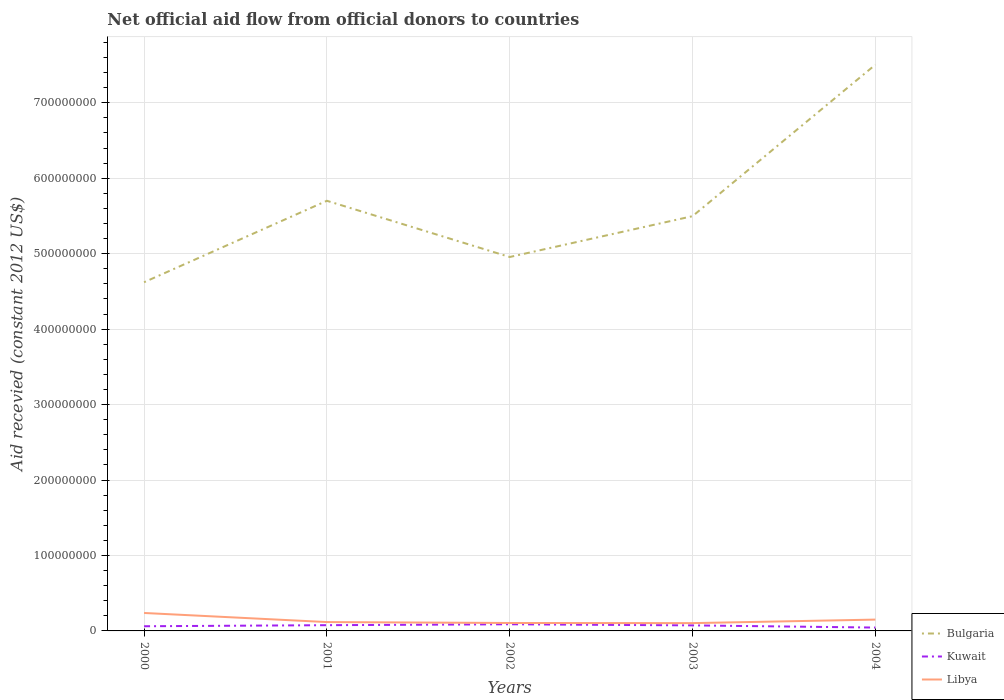How many different coloured lines are there?
Offer a terse response. 3. Across all years, what is the maximum total aid received in Libya?
Your answer should be compact. 1.03e+07. In which year was the total aid received in Libya maximum?
Offer a terse response. 2003. What is the total total aid received in Bulgaria in the graph?
Offer a very short reply. -2.88e+08. What is the difference between the highest and the second highest total aid received in Kuwait?
Ensure brevity in your answer.  4.38e+06. Is the total aid received in Kuwait strictly greater than the total aid received in Bulgaria over the years?
Ensure brevity in your answer.  Yes. How many lines are there?
Your response must be concise. 3. How many years are there in the graph?
Make the answer very short. 5. What is the difference between two consecutive major ticks on the Y-axis?
Your answer should be very brief. 1.00e+08. Are the values on the major ticks of Y-axis written in scientific E-notation?
Ensure brevity in your answer.  No. Does the graph contain grids?
Provide a short and direct response. Yes. Where does the legend appear in the graph?
Make the answer very short. Bottom right. What is the title of the graph?
Your response must be concise. Net official aid flow from official donors to countries. Does "Italy" appear as one of the legend labels in the graph?
Give a very brief answer. No. What is the label or title of the X-axis?
Ensure brevity in your answer.  Years. What is the label or title of the Y-axis?
Provide a succinct answer. Aid recevied (constant 2012 US$). What is the Aid recevied (constant 2012 US$) in Bulgaria in 2000?
Make the answer very short. 4.62e+08. What is the Aid recevied (constant 2012 US$) of Kuwait in 2000?
Your answer should be very brief. 6.19e+06. What is the Aid recevied (constant 2012 US$) of Libya in 2000?
Provide a short and direct response. 2.38e+07. What is the Aid recevied (constant 2012 US$) in Bulgaria in 2001?
Your answer should be compact. 5.70e+08. What is the Aid recevied (constant 2012 US$) of Kuwait in 2001?
Ensure brevity in your answer.  7.60e+06. What is the Aid recevied (constant 2012 US$) in Libya in 2001?
Provide a short and direct response. 1.17e+07. What is the Aid recevied (constant 2012 US$) in Bulgaria in 2002?
Your response must be concise. 4.96e+08. What is the Aid recevied (constant 2012 US$) of Kuwait in 2002?
Ensure brevity in your answer.  8.82e+06. What is the Aid recevied (constant 2012 US$) of Libya in 2002?
Your response must be concise. 1.05e+07. What is the Aid recevied (constant 2012 US$) in Bulgaria in 2003?
Make the answer very short. 5.50e+08. What is the Aid recevied (constant 2012 US$) of Kuwait in 2003?
Offer a terse response. 7.34e+06. What is the Aid recevied (constant 2012 US$) of Libya in 2003?
Ensure brevity in your answer.  1.03e+07. What is the Aid recevied (constant 2012 US$) of Bulgaria in 2004?
Offer a terse response. 7.50e+08. What is the Aid recevied (constant 2012 US$) of Kuwait in 2004?
Make the answer very short. 4.44e+06. What is the Aid recevied (constant 2012 US$) of Libya in 2004?
Give a very brief answer. 1.50e+07. Across all years, what is the maximum Aid recevied (constant 2012 US$) in Bulgaria?
Keep it short and to the point. 7.50e+08. Across all years, what is the maximum Aid recevied (constant 2012 US$) of Kuwait?
Your answer should be compact. 8.82e+06. Across all years, what is the maximum Aid recevied (constant 2012 US$) in Libya?
Offer a terse response. 2.38e+07. Across all years, what is the minimum Aid recevied (constant 2012 US$) of Bulgaria?
Ensure brevity in your answer.  4.62e+08. Across all years, what is the minimum Aid recevied (constant 2012 US$) in Kuwait?
Your answer should be compact. 4.44e+06. Across all years, what is the minimum Aid recevied (constant 2012 US$) of Libya?
Keep it short and to the point. 1.03e+07. What is the total Aid recevied (constant 2012 US$) in Bulgaria in the graph?
Keep it short and to the point. 2.83e+09. What is the total Aid recevied (constant 2012 US$) in Kuwait in the graph?
Offer a very short reply. 3.44e+07. What is the total Aid recevied (constant 2012 US$) of Libya in the graph?
Make the answer very short. 7.14e+07. What is the difference between the Aid recevied (constant 2012 US$) of Bulgaria in 2000 and that in 2001?
Offer a very short reply. -1.08e+08. What is the difference between the Aid recevied (constant 2012 US$) of Kuwait in 2000 and that in 2001?
Your answer should be very brief. -1.41e+06. What is the difference between the Aid recevied (constant 2012 US$) in Libya in 2000 and that in 2001?
Give a very brief answer. 1.21e+07. What is the difference between the Aid recevied (constant 2012 US$) in Bulgaria in 2000 and that in 2002?
Your answer should be very brief. -3.34e+07. What is the difference between the Aid recevied (constant 2012 US$) of Kuwait in 2000 and that in 2002?
Provide a succinct answer. -2.63e+06. What is the difference between the Aid recevied (constant 2012 US$) in Libya in 2000 and that in 2002?
Offer a terse response. 1.33e+07. What is the difference between the Aid recevied (constant 2012 US$) of Bulgaria in 2000 and that in 2003?
Offer a terse response. -8.76e+07. What is the difference between the Aid recevied (constant 2012 US$) of Kuwait in 2000 and that in 2003?
Make the answer very short. -1.15e+06. What is the difference between the Aid recevied (constant 2012 US$) of Libya in 2000 and that in 2003?
Provide a short and direct response. 1.34e+07. What is the difference between the Aid recevied (constant 2012 US$) in Bulgaria in 2000 and that in 2004?
Make the answer very short. -2.88e+08. What is the difference between the Aid recevied (constant 2012 US$) in Kuwait in 2000 and that in 2004?
Your response must be concise. 1.75e+06. What is the difference between the Aid recevied (constant 2012 US$) of Libya in 2000 and that in 2004?
Provide a succinct answer. 8.78e+06. What is the difference between the Aid recevied (constant 2012 US$) in Bulgaria in 2001 and that in 2002?
Give a very brief answer. 7.45e+07. What is the difference between the Aid recevied (constant 2012 US$) in Kuwait in 2001 and that in 2002?
Your response must be concise. -1.22e+06. What is the difference between the Aid recevied (constant 2012 US$) in Libya in 2001 and that in 2002?
Your response must be concise. 1.22e+06. What is the difference between the Aid recevied (constant 2012 US$) in Bulgaria in 2001 and that in 2003?
Your response must be concise. 2.04e+07. What is the difference between the Aid recevied (constant 2012 US$) in Libya in 2001 and that in 2003?
Your answer should be very brief. 1.39e+06. What is the difference between the Aid recevied (constant 2012 US$) of Bulgaria in 2001 and that in 2004?
Your answer should be very brief. -1.80e+08. What is the difference between the Aid recevied (constant 2012 US$) of Kuwait in 2001 and that in 2004?
Your answer should be compact. 3.16e+06. What is the difference between the Aid recevied (constant 2012 US$) in Libya in 2001 and that in 2004?
Provide a succinct answer. -3.28e+06. What is the difference between the Aid recevied (constant 2012 US$) in Bulgaria in 2002 and that in 2003?
Ensure brevity in your answer.  -5.41e+07. What is the difference between the Aid recevied (constant 2012 US$) in Kuwait in 2002 and that in 2003?
Ensure brevity in your answer.  1.48e+06. What is the difference between the Aid recevied (constant 2012 US$) in Libya in 2002 and that in 2003?
Keep it short and to the point. 1.70e+05. What is the difference between the Aid recevied (constant 2012 US$) in Bulgaria in 2002 and that in 2004?
Your answer should be compact. -2.55e+08. What is the difference between the Aid recevied (constant 2012 US$) in Kuwait in 2002 and that in 2004?
Provide a succinct answer. 4.38e+06. What is the difference between the Aid recevied (constant 2012 US$) in Libya in 2002 and that in 2004?
Provide a short and direct response. -4.50e+06. What is the difference between the Aid recevied (constant 2012 US$) in Bulgaria in 2003 and that in 2004?
Give a very brief answer. -2.01e+08. What is the difference between the Aid recevied (constant 2012 US$) in Kuwait in 2003 and that in 2004?
Offer a very short reply. 2.90e+06. What is the difference between the Aid recevied (constant 2012 US$) in Libya in 2003 and that in 2004?
Ensure brevity in your answer.  -4.67e+06. What is the difference between the Aid recevied (constant 2012 US$) of Bulgaria in 2000 and the Aid recevied (constant 2012 US$) of Kuwait in 2001?
Offer a terse response. 4.54e+08. What is the difference between the Aid recevied (constant 2012 US$) in Bulgaria in 2000 and the Aid recevied (constant 2012 US$) in Libya in 2001?
Offer a very short reply. 4.50e+08. What is the difference between the Aid recevied (constant 2012 US$) in Kuwait in 2000 and the Aid recevied (constant 2012 US$) in Libya in 2001?
Ensure brevity in your answer.  -5.54e+06. What is the difference between the Aid recevied (constant 2012 US$) of Bulgaria in 2000 and the Aid recevied (constant 2012 US$) of Kuwait in 2002?
Give a very brief answer. 4.53e+08. What is the difference between the Aid recevied (constant 2012 US$) in Bulgaria in 2000 and the Aid recevied (constant 2012 US$) in Libya in 2002?
Provide a succinct answer. 4.52e+08. What is the difference between the Aid recevied (constant 2012 US$) in Kuwait in 2000 and the Aid recevied (constant 2012 US$) in Libya in 2002?
Make the answer very short. -4.32e+06. What is the difference between the Aid recevied (constant 2012 US$) in Bulgaria in 2000 and the Aid recevied (constant 2012 US$) in Kuwait in 2003?
Your answer should be very brief. 4.55e+08. What is the difference between the Aid recevied (constant 2012 US$) in Bulgaria in 2000 and the Aid recevied (constant 2012 US$) in Libya in 2003?
Offer a terse response. 4.52e+08. What is the difference between the Aid recevied (constant 2012 US$) of Kuwait in 2000 and the Aid recevied (constant 2012 US$) of Libya in 2003?
Ensure brevity in your answer.  -4.15e+06. What is the difference between the Aid recevied (constant 2012 US$) of Bulgaria in 2000 and the Aid recevied (constant 2012 US$) of Kuwait in 2004?
Offer a terse response. 4.58e+08. What is the difference between the Aid recevied (constant 2012 US$) in Bulgaria in 2000 and the Aid recevied (constant 2012 US$) in Libya in 2004?
Provide a short and direct response. 4.47e+08. What is the difference between the Aid recevied (constant 2012 US$) of Kuwait in 2000 and the Aid recevied (constant 2012 US$) of Libya in 2004?
Your answer should be very brief. -8.82e+06. What is the difference between the Aid recevied (constant 2012 US$) of Bulgaria in 2001 and the Aid recevied (constant 2012 US$) of Kuwait in 2002?
Your answer should be very brief. 5.61e+08. What is the difference between the Aid recevied (constant 2012 US$) of Bulgaria in 2001 and the Aid recevied (constant 2012 US$) of Libya in 2002?
Your response must be concise. 5.60e+08. What is the difference between the Aid recevied (constant 2012 US$) in Kuwait in 2001 and the Aid recevied (constant 2012 US$) in Libya in 2002?
Keep it short and to the point. -2.91e+06. What is the difference between the Aid recevied (constant 2012 US$) of Bulgaria in 2001 and the Aid recevied (constant 2012 US$) of Kuwait in 2003?
Give a very brief answer. 5.63e+08. What is the difference between the Aid recevied (constant 2012 US$) in Bulgaria in 2001 and the Aid recevied (constant 2012 US$) in Libya in 2003?
Ensure brevity in your answer.  5.60e+08. What is the difference between the Aid recevied (constant 2012 US$) of Kuwait in 2001 and the Aid recevied (constant 2012 US$) of Libya in 2003?
Give a very brief answer. -2.74e+06. What is the difference between the Aid recevied (constant 2012 US$) in Bulgaria in 2001 and the Aid recevied (constant 2012 US$) in Kuwait in 2004?
Ensure brevity in your answer.  5.66e+08. What is the difference between the Aid recevied (constant 2012 US$) of Bulgaria in 2001 and the Aid recevied (constant 2012 US$) of Libya in 2004?
Provide a succinct answer. 5.55e+08. What is the difference between the Aid recevied (constant 2012 US$) in Kuwait in 2001 and the Aid recevied (constant 2012 US$) in Libya in 2004?
Provide a short and direct response. -7.41e+06. What is the difference between the Aid recevied (constant 2012 US$) in Bulgaria in 2002 and the Aid recevied (constant 2012 US$) in Kuwait in 2003?
Offer a very short reply. 4.88e+08. What is the difference between the Aid recevied (constant 2012 US$) in Bulgaria in 2002 and the Aid recevied (constant 2012 US$) in Libya in 2003?
Your answer should be compact. 4.85e+08. What is the difference between the Aid recevied (constant 2012 US$) in Kuwait in 2002 and the Aid recevied (constant 2012 US$) in Libya in 2003?
Provide a succinct answer. -1.52e+06. What is the difference between the Aid recevied (constant 2012 US$) in Bulgaria in 2002 and the Aid recevied (constant 2012 US$) in Kuwait in 2004?
Make the answer very short. 4.91e+08. What is the difference between the Aid recevied (constant 2012 US$) in Bulgaria in 2002 and the Aid recevied (constant 2012 US$) in Libya in 2004?
Keep it short and to the point. 4.81e+08. What is the difference between the Aid recevied (constant 2012 US$) of Kuwait in 2002 and the Aid recevied (constant 2012 US$) of Libya in 2004?
Ensure brevity in your answer.  -6.19e+06. What is the difference between the Aid recevied (constant 2012 US$) of Bulgaria in 2003 and the Aid recevied (constant 2012 US$) of Kuwait in 2004?
Ensure brevity in your answer.  5.45e+08. What is the difference between the Aid recevied (constant 2012 US$) of Bulgaria in 2003 and the Aid recevied (constant 2012 US$) of Libya in 2004?
Offer a very short reply. 5.35e+08. What is the difference between the Aid recevied (constant 2012 US$) of Kuwait in 2003 and the Aid recevied (constant 2012 US$) of Libya in 2004?
Provide a succinct answer. -7.67e+06. What is the average Aid recevied (constant 2012 US$) of Bulgaria per year?
Give a very brief answer. 5.66e+08. What is the average Aid recevied (constant 2012 US$) in Kuwait per year?
Your answer should be very brief. 6.88e+06. What is the average Aid recevied (constant 2012 US$) of Libya per year?
Give a very brief answer. 1.43e+07. In the year 2000, what is the difference between the Aid recevied (constant 2012 US$) of Bulgaria and Aid recevied (constant 2012 US$) of Kuwait?
Keep it short and to the point. 4.56e+08. In the year 2000, what is the difference between the Aid recevied (constant 2012 US$) of Bulgaria and Aid recevied (constant 2012 US$) of Libya?
Keep it short and to the point. 4.38e+08. In the year 2000, what is the difference between the Aid recevied (constant 2012 US$) of Kuwait and Aid recevied (constant 2012 US$) of Libya?
Offer a very short reply. -1.76e+07. In the year 2001, what is the difference between the Aid recevied (constant 2012 US$) in Bulgaria and Aid recevied (constant 2012 US$) in Kuwait?
Your response must be concise. 5.62e+08. In the year 2001, what is the difference between the Aid recevied (constant 2012 US$) of Bulgaria and Aid recevied (constant 2012 US$) of Libya?
Your answer should be very brief. 5.58e+08. In the year 2001, what is the difference between the Aid recevied (constant 2012 US$) in Kuwait and Aid recevied (constant 2012 US$) in Libya?
Keep it short and to the point. -4.13e+06. In the year 2002, what is the difference between the Aid recevied (constant 2012 US$) in Bulgaria and Aid recevied (constant 2012 US$) in Kuwait?
Ensure brevity in your answer.  4.87e+08. In the year 2002, what is the difference between the Aid recevied (constant 2012 US$) of Bulgaria and Aid recevied (constant 2012 US$) of Libya?
Keep it short and to the point. 4.85e+08. In the year 2002, what is the difference between the Aid recevied (constant 2012 US$) of Kuwait and Aid recevied (constant 2012 US$) of Libya?
Make the answer very short. -1.69e+06. In the year 2003, what is the difference between the Aid recevied (constant 2012 US$) of Bulgaria and Aid recevied (constant 2012 US$) of Kuwait?
Give a very brief answer. 5.42e+08. In the year 2003, what is the difference between the Aid recevied (constant 2012 US$) of Bulgaria and Aid recevied (constant 2012 US$) of Libya?
Keep it short and to the point. 5.39e+08. In the year 2004, what is the difference between the Aid recevied (constant 2012 US$) of Bulgaria and Aid recevied (constant 2012 US$) of Kuwait?
Your response must be concise. 7.46e+08. In the year 2004, what is the difference between the Aid recevied (constant 2012 US$) in Bulgaria and Aid recevied (constant 2012 US$) in Libya?
Make the answer very short. 7.35e+08. In the year 2004, what is the difference between the Aid recevied (constant 2012 US$) of Kuwait and Aid recevied (constant 2012 US$) of Libya?
Offer a very short reply. -1.06e+07. What is the ratio of the Aid recevied (constant 2012 US$) in Bulgaria in 2000 to that in 2001?
Provide a succinct answer. 0.81. What is the ratio of the Aid recevied (constant 2012 US$) of Kuwait in 2000 to that in 2001?
Ensure brevity in your answer.  0.81. What is the ratio of the Aid recevied (constant 2012 US$) of Libya in 2000 to that in 2001?
Ensure brevity in your answer.  2.03. What is the ratio of the Aid recevied (constant 2012 US$) in Bulgaria in 2000 to that in 2002?
Your response must be concise. 0.93. What is the ratio of the Aid recevied (constant 2012 US$) in Kuwait in 2000 to that in 2002?
Offer a very short reply. 0.7. What is the ratio of the Aid recevied (constant 2012 US$) of Libya in 2000 to that in 2002?
Give a very brief answer. 2.26. What is the ratio of the Aid recevied (constant 2012 US$) of Bulgaria in 2000 to that in 2003?
Keep it short and to the point. 0.84. What is the ratio of the Aid recevied (constant 2012 US$) of Kuwait in 2000 to that in 2003?
Provide a short and direct response. 0.84. What is the ratio of the Aid recevied (constant 2012 US$) in Libya in 2000 to that in 2003?
Ensure brevity in your answer.  2.3. What is the ratio of the Aid recevied (constant 2012 US$) in Bulgaria in 2000 to that in 2004?
Ensure brevity in your answer.  0.62. What is the ratio of the Aid recevied (constant 2012 US$) in Kuwait in 2000 to that in 2004?
Provide a succinct answer. 1.39. What is the ratio of the Aid recevied (constant 2012 US$) of Libya in 2000 to that in 2004?
Your answer should be compact. 1.58. What is the ratio of the Aid recevied (constant 2012 US$) of Bulgaria in 2001 to that in 2002?
Offer a very short reply. 1.15. What is the ratio of the Aid recevied (constant 2012 US$) in Kuwait in 2001 to that in 2002?
Provide a succinct answer. 0.86. What is the ratio of the Aid recevied (constant 2012 US$) of Libya in 2001 to that in 2002?
Offer a very short reply. 1.12. What is the ratio of the Aid recevied (constant 2012 US$) of Bulgaria in 2001 to that in 2003?
Ensure brevity in your answer.  1.04. What is the ratio of the Aid recevied (constant 2012 US$) in Kuwait in 2001 to that in 2003?
Give a very brief answer. 1.04. What is the ratio of the Aid recevied (constant 2012 US$) of Libya in 2001 to that in 2003?
Provide a short and direct response. 1.13. What is the ratio of the Aid recevied (constant 2012 US$) in Bulgaria in 2001 to that in 2004?
Provide a short and direct response. 0.76. What is the ratio of the Aid recevied (constant 2012 US$) of Kuwait in 2001 to that in 2004?
Your answer should be very brief. 1.71. What is the ratio of the Aid recevied (constant 2012 US$) in Libya in 2001 to that in 2004?
Provide a succinct answer. 0.78. What is the ratio of the Aid recevied (constant 2012 US$) in Bulgaria in 2002 to that in 2003?
Keep it short and to the point. 0.9. What is the ratio of the Aid recevied (constant 2012 US$) of Kuwait in 2002 to that in 2003?
Keep it short and to the point. 1.2. What is the ratio of the Aid recevied (constant 2012 US$) of Libya in 2002 to that in 2003?
Your response must be concise. 1.02. What is the ratio of the Aid recevied (constant 2012 US$) in Bulgaria in 2002 to that in 2004?
Your answer should be very brief. 0.66. What is the ratio of the Aid recevied (constant 2012 US$) of Kuwait in 2002 to that in 2004?
Offer a very short reply. 1.99. What is the ratio of the Aid recevied (constant 2012 US$) in Libya in 2002 to that in 2004?
Provide a succinct answer. 0.7. What is the ratio of the Aid recevied (constant 2012 US$) of Bulgaria in 2003 to that in 2004?
Offer a terse response. 0.73. What is the ratio of the Aid recevied (constant 2012 US$) in Kuwait in 2003 to that in 2004?
Ensure brevity in your answer.  1.65. What is the ratio of the Aid recevied (constant 2012 US$) in Libya in 2003 to that in 2004?
Your answer should be compact. 0.69. What is the difference between the highest and the second highest Aid recevied (constant 2012 US$) in Bulgaria?
Provide a succinct answer. 1.80e+08. What is the difference between the highest and the second highest Aid recevied (constant 2012 US$) of Kuwait?
Provide a short and direct response. 1.22e+06. What is the difference between the highest and the second highest Aid recevied (constant 2012 US$) of Libya?
Your answer should be very brief. 8.78e+06. What is the difference between the highest and the lowest Aid recevied (constant 2012 US$) of Bulgaria?
Provide a succinct answer. 2.88e+08. What is the difference between the highest and the lowest Aid recevied (constant 2012 US$) in Kuwait?
Your answer should be compact. 4.38e+06. What is the difference between the highest and the lowest Aid recevied (constant 2012 US$) in Libya?
Offer a very short reply. 1.34e+07. 